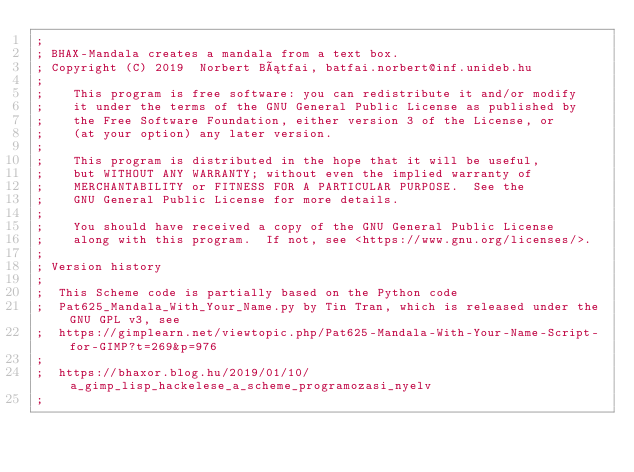<code> <loc_0><loc_0><loc_500><loc_500><_Scheme_>;
; BHAX-Mandala creates a mandala from a text box.
; Copyright (C) 2019  Norbert Bátfai, batfai.norbert@inf.unideb.hu
;
;    This program is free software: you can redistribute it and/or modify
;    it under the terms of the GNU General Public License as published by
;    the Free Software Foundation, either version 3 of the License, or
;    (at your option) any later version.
;
;    This program is distributed in the hope that it will be useful,
;    but WITHOUT ANY WARRANTY; without even the implied warranty of
;    MERCHANTABILITY or FITNESS FOR A PARTICULAR PURPOSE.  See the
;    GNU General Public License for more details.
;
;    You should have received a copy of the GNU General Public License
;    along with this program.  If not, see <https://www.gnu.org/licenses/>.
;
; Version history
;
;  This Scheme code is partially based on the Python code 
;  Pat625_Mandala_With_Your_Name.py by Tin Tran, which is released under the GNU GPL v3, see 
;  https://gimplearn.net/viewtopic.php/Pat625-Mandala-With-Your-Name-Script-for-GIMP?t=269&p=976
;
;  https://bhaxor.blog.hu/2019/01/10/a_gimp_lisp_hackelese_a_scheme_programozasi_nyelv
; 
</code> 